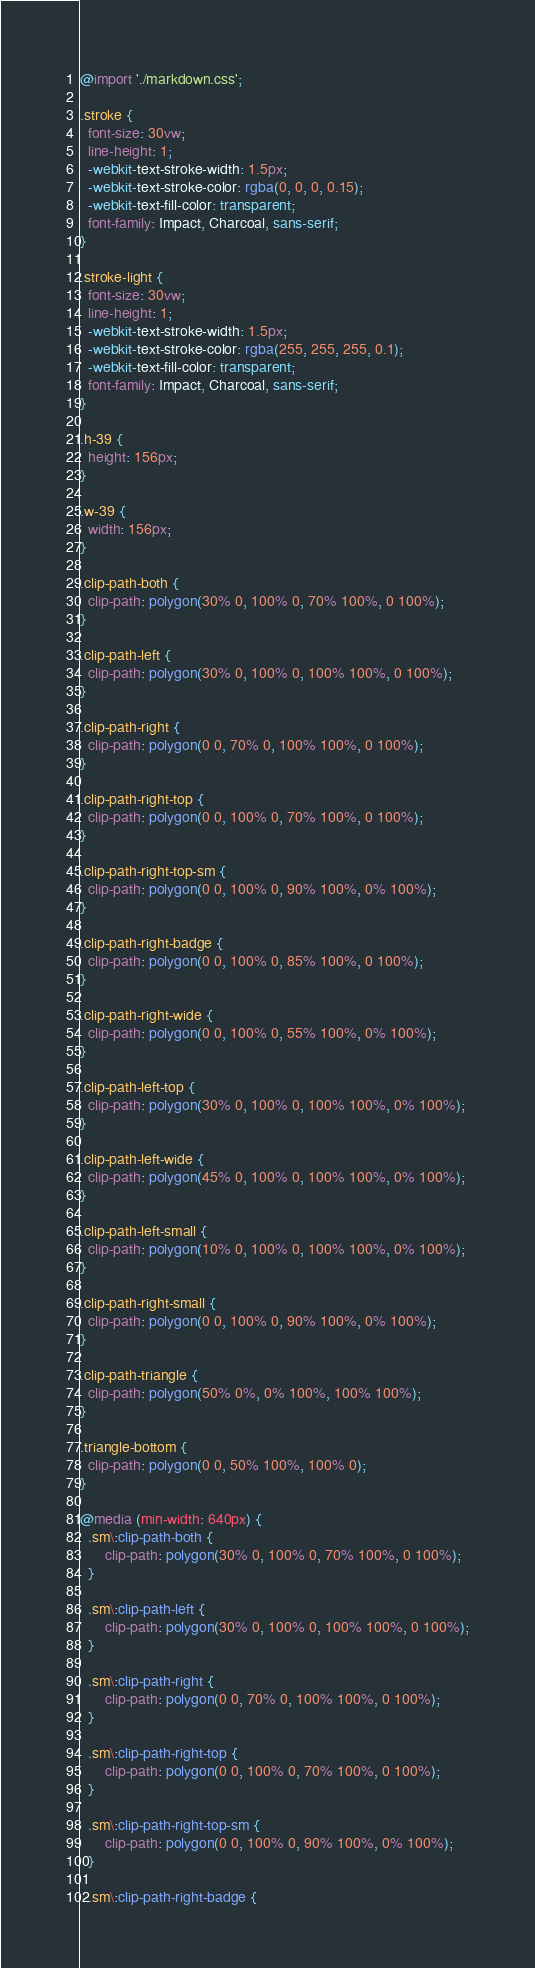<code> <loc_0><loc_0><loc_500><loc_500><_CSS_>@import './markdown.css';

.stroke {
  font-size: 30vw;
  line-height: 1;
  -webkit-text-stroke-width: 1.5px;
  -webkit-text-stroke-color: rgba(0, 0, 0, 0.15);
  -webkit-text-fill-color: transparent;
  font-family: Impact, Charcoal, sans-serif;
}

.stroke-light {
  font-size: 30vw;
  line-height: 1;
  -webkit-text-stroke-width: 1.5px;
  -webkit-text-stroke-color: rgba(255, 255, 255, 0.1);
  -webkit-text-fill-color: transparent;
  font-family: Impact, Charcoal, sans-serif;
}

.h-39 {
  height: 156px;
}

.w-39 {
  width: 156px;
}

.clip-path-both {
  clip-path: polygon(30% 0, 100% 0, 70% 100%, 0 100%);
}

.clip-path-left {
  clip-path: polygon(30% 0, 100% 0, 100% 100%, 0 100%);
}

.clip-path-right {
  clip-path: polygon(0 0, 70% 0, 100% 100%, 0 100%);
}

.clip-path-right-top {
  clip-path: polygon(0 0, 100% 0, 70% 100%, 0 100%);
}

.clip-path-right-top-sm {
  clip-path: polygon(0 0, 100% 0, 90% 100%, 0% 100%);
}

.clip-path-right-badge {
  clip-path: polygon(0 0, 100% 0, 85% 100%, 0 100%);
}

.clip-path-right-wide {
  clip-path: polygon(0 0, 100% 0, 55% 100%, 0% 100%);
}

.clip-path-left-top {
  clip-path: polygon(30% 0, 100% 0, 100% 100%, 0% 100%);
}

.clip-path-left-wide {
  clip-path: polygon(45% 0, 100% 0, 100% 100%, 0% 100%);
}

.clip-path-left-small {
  clip-path: polygon(10% 0, 100% 0, 100% 100%, 0% 100%);
}

.clip-path-right-small {
  clip-path: polygon(0 0, 100% 0, 90% 100%, 0% 100%);
}

.clip-path-triangle {
  clip-path: polygon(50% 0%, 0% 100%, 100% 100%);
}

.triangle-bottom {
  clip-path: polygon(0 0, 50% 100%, 100% 0);
}

@media (min-width: 640px) {
  .sm\:clip-path-both {
      clip-path: polygon(30% 0, 100% 0, 70% 100%, 0 100%);
  }
  
  .sm\:clip-path-left {
      clip-path: polygon(30% 0, 100% 0, 100% 100%, 0 100%);
  }
  
  .sm\:clip-path-right {
      clip-path: polygon(0 0, 70% 0, 100% 100%, 0 100%);
  }
  
  .sm\:clip-path-right-top {
      clip-path: polygon(0 0, 100% 0, 70% 100%, 0 100%);
  }
  
  .sm\:clip-path-right-top-sm {
      clip-path: polygon(0 0, 100% 0, 90% 100%, 0% 100%);
  }
  
  .sm\:clip-path-right-badge {</code> 